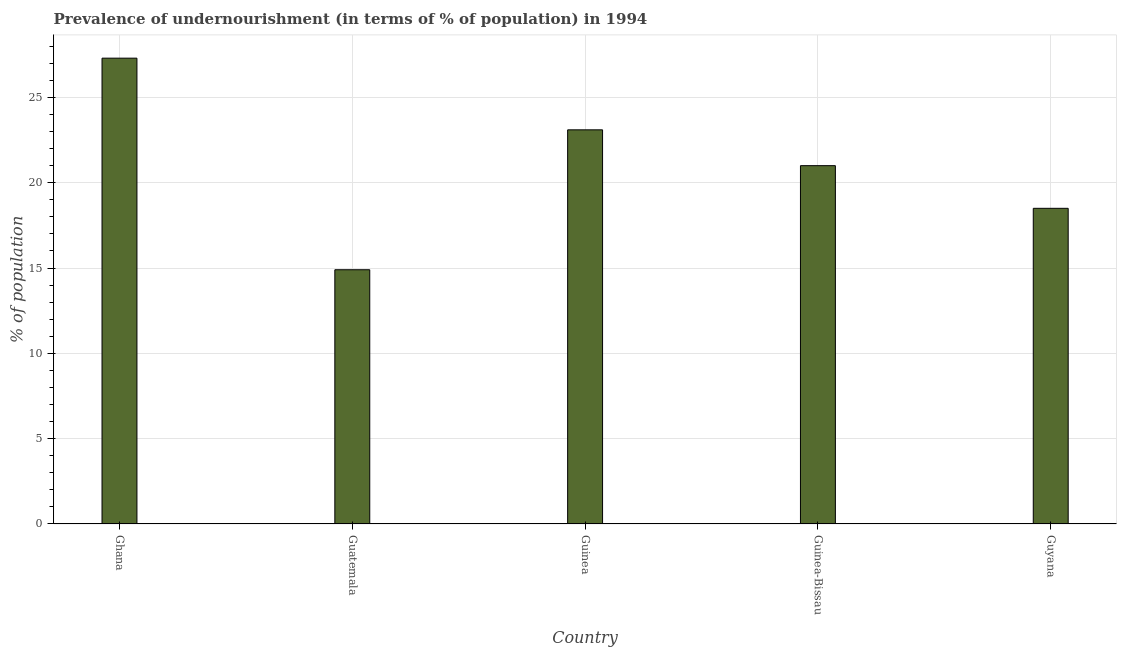Does the graph contain any zero values?
Provide a short and direct response. No. Does the graph contain grids?
Offer a very short reply. Yes. What is the title of the graph?
Offer a terse response. Prevalence of undernourishment (in terms of % of population) in 1994. What is the label or title of the X-axis?
Your answer should be very brief. Country. What is the label or title of the Y-axis?
Give a very brief answer. % of population. What is the percentage of undernourished population in Guatemala?
Give a very brief answer. 14.9. Across all countries, what is the maximum percentage of undernourished population?
Your answer should be compact. 27.3. Across all countries, what is the minimum percentage of undernourished population?
Your response must be concise. 14.9. In which country was the percentage of undernourished population maximum?
Your answer should be very brief. Ghana. In which country was the percentage of undernourished population minimum?
Provide a short and direct response. Guatemala. What is the sum of the percentage of undernourished population?
Offer a very short reply. 104.8. What is the average percentage of undernourished population per country?
Your answer should be very brief. 20.96. What is the median percentage of undernourished population?
Offer a very short reply. 21. In how many countries, is the percentage of undernourished population greater than 21 %?
Make the answer very short. 2. Is the percentage of undernourished population in Guinea less than that in Guinea-Bissau?
Keep it short and to the point. No. Is the difference between the percentage of undernourished population in Ghana and Guinea-Bissau greater than the difference between any two countries?
Your answer should be compact. No. Is the sum of the percentage of undernourished population in Ghana and Guyana greater than the maximum percentage of undernourished population across all countries?
Provide a short and direct response. Yes. In how many countries, is the percentage of undernourished population greater than the average percentage of undernourished population taken over all countries?
Give a very brief answer. 3. How many bars are there?
Your answer should be compact. 5. Are all the bars in the graph horizontal?
Provide a short and direct response. No. What is the % of population in Ghana?
Make the answer very short. 27.3. What is the % of population of Guatemala?
Ensure brevity in your answer.  14.9. What is the % of population in Guinea?
Offer a terse response. 23.1. What is the % of population of Guyana?
Offer a terse response. 18.5. What is the difference between the % of population in Ghana and Guatemala?
Offer a terse response. 12.4. What is the difference between the % of population in Ghana and Guinea-Bissau?
Ensure brevity in your answer.  6.3. What is the difference between the % of population in Ghana and Guyana?
Ensure brevity in your answer.  8.8. What is the difference between the % of population in Guatemala and Guyana?
Offer a terse response. -3.6. What is the difference between the % of population in Guinea and Guinea-Bissau?
Your answer should be compact. 2.1. What is the difference between the % of population in Guinea and Guyana?
Your response must be concise. 4.6. What is the difference between the % of population in Guinea-Bissau and Guyana?
Ensure brevity in your answer.  2.5. What is the ratio of the % of population in Ghana to that in Guatemala?
Ensure brevity in your answer.  1.83. What is the ratio of the % of population in Ghana to that in Guinea?
Provide a succinct answer. 1.18. What is the ratio of the % of population in Ghana to that in Guinea-Bissau?
Ensure brevity in your answer.  1.3. What is the ratio of the % of population in Ghana to that in Guyana?
Provide a short and direct response. 1.48. What is the ratio of the % of population in Guatemala to that in Guinea?
Ensure brevity in your answer.  0.65. What is the ratio of the % of population in Guatemala to that in Guinea-Bissau?
Make the answer very short. 0.71. What is the ratio of the % of population in Guatemala to that in Guyana?
Offer a very short reply. 0.81. What is the ratio of the % of population in Guinea to that in Guinea-Bissau?
Offer a very short reply. 1.1. What is the ratio of the % of population in Guinea to that in Guyana?
Ensure brevity in your answer.  1.25. What is the ratio of the % of population in Guinea-Bissau to that in Guyana?
Offer a very short reply. 1.14. 